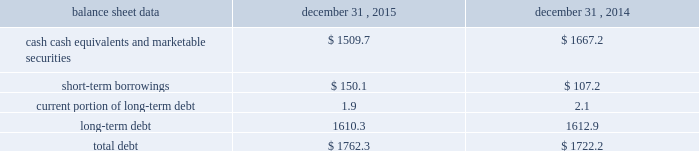Management 2019s discussion and analysis of financial condition and results of operations 2013 ( continued ) ( amounts in millions , except per share amounts ) financing activities net cash used in financing activities during 2015 primarily related to the repurchase of our common stock and payment of dividends .
We repurchased 13.6 shares of our common stock for an aggregate cost of $ 285.2 , including fees , and made dividend payments of $ 195.5 on our common stock .
Net cash used in financing activities during 2014 primarily related to the purchase of long-term debt , the repurchase of our common stock and payment of dividends .
We redeemed all $ 350.0 in aggregate principal amount of our 6.25% ( 6.25 % ) notes , repurchased 14.9 shares of our common stock for an aggregate cost of $ 275.1 , including fees , and made dividend payments of $ 159.0 on our common stock .
This was offset by the issuance of $ 500.0 in aggregate principal amount of our 4.20% ( 4.20 % ) notes .
Foreign exchange rate changes the effect of foreign exchange rate changes on cash and cash equivalents included in the consolidated statements of cash flows resulted in a decrease of $ 156.1 in 2015 .
The decrease was primarily a result of the u.s .
Dollar being stronger than several foreign currencies , including the australian dollar , brazilian real , canadian dollar , euro and south african rand as of december 31 , 2015 compared to december 31 , 2014 .
The effect of foreign exchange rate changes on cash and cash equivalents included in the consolidated statements of cash flows resulted in a decrease of $ 101.0 in 2014 .
The decrease was primarily a result of the u.s .
Dollar being stronger than several foreign currencies , including the australian dollar , brazilian real , canadian dollar and euro as of december 31 , 2014 compared to december 31 , 2013. .
Liquidity outlook we expect our cash flow from operations , cash and cash equivalents to be sufficient to meet our anticipated operating requirements at a minimum for the next twelve months .
We also have a committed corporate credit facility as well as uncommitted facilities available to support our operating needs .
We continue to maintain a disciplined approach to managing liquidity , with flexibility over significant uses of cash , including our capital expenditures , cash used for new acquisitions , our common stock repurchase program and our common stock dividends .
From time to time , we evaluate market conditions and financing alternatives for opportunities to raise additional funds or otherwise improve our liquidity profile , enhance our financial flexibility and manage market risk .
Our ability to access the capital markets depends on a number of factors , which include those specific to us , such as our credit rating , and those related to the financial markets , such as the amount or terms of available credit .
There can be no guarantee that we would be able to access new sources of liquidity on commercially reasonable terms , or at all .
Funding requirements our most significant funding requirements include our operations , non-cancelable operating lease obligations , capital expenditures , acquisitions , common stock dividends , taxes , debt service and contributions to pension and postretirement plans .
Additionally , we may be required to make payments to minority shareholders in certain subsidiaries if they exercise their options to sell us their equity interests. .
If all the balance of cash cash equivalents and marketable securities was used to repay debt , what would be the net debt at the end of 2015? 
Computations: (1762.3 - 1509.7)
Answer: 252.6. 